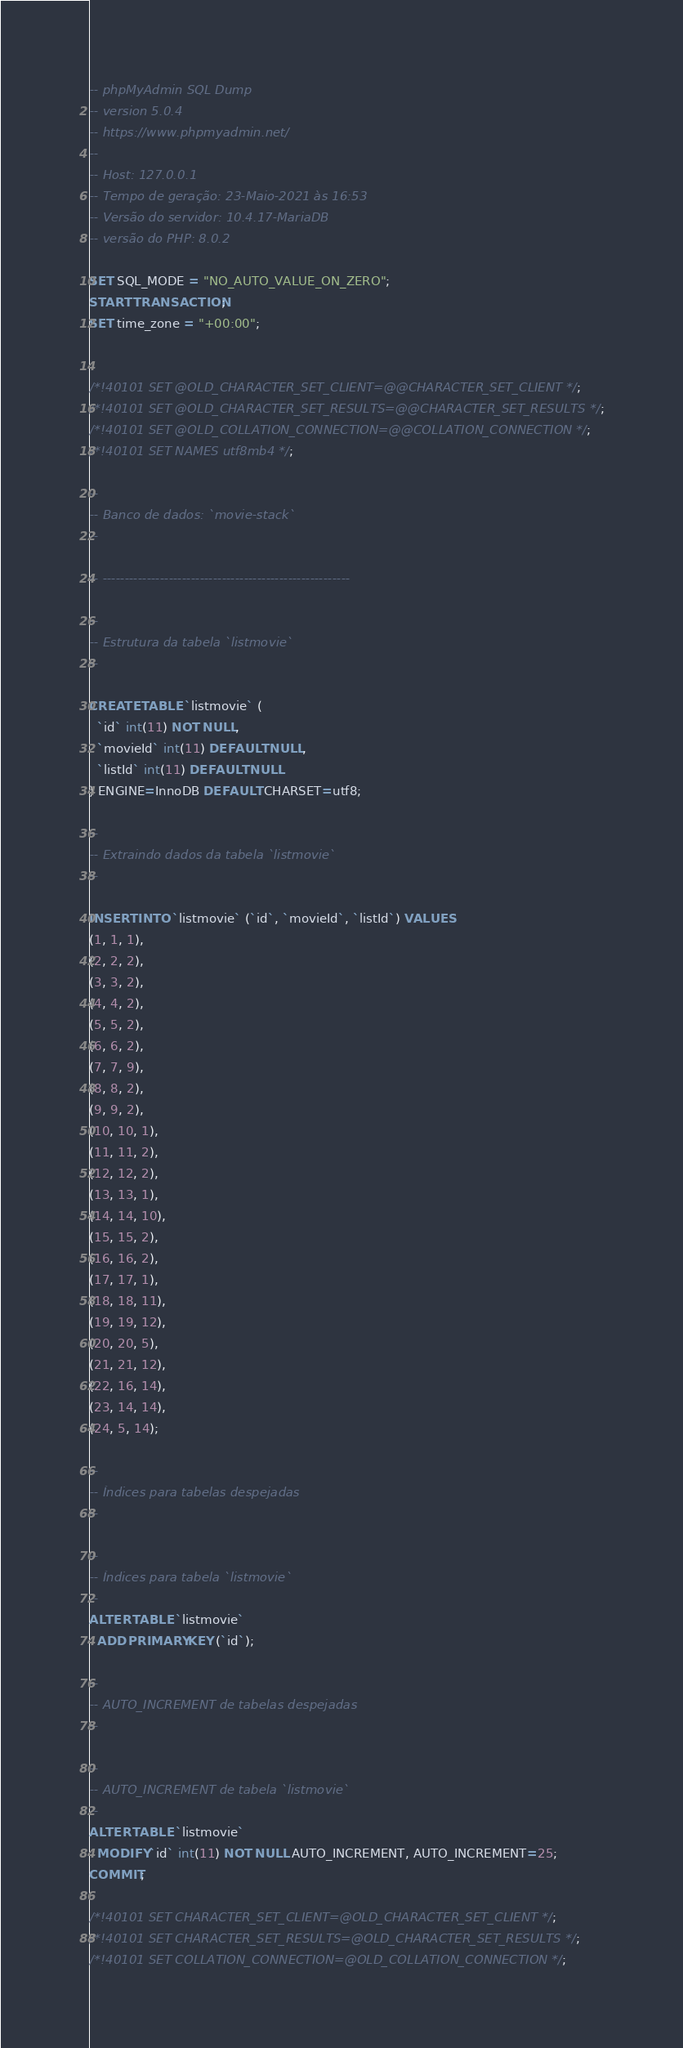<code> <loc_0><loc_0><loc_500><loc_500><_SQL_>-- phpMyAdmin SQL Dump
-- version 5.0.4
-- https://www.phpmyadmin.net/
--
-- Host: 127.0.0.1
-- Tempo de geração: 23-Maio-2021 às 16:53
-- Versão do servidor: 10.4.17-MariaDB
-- versão do PHP: 8.0.2

SET SQL_MODE = "NO_AUTO_VALUE_ON_ZERO";
START TRANSACTION;
SET time_zone = "+00:00";


/*!40101 SET @OLD_CHARACTER_SET_CLIENT=@@CHARACTER_SET_CLIENT */;
/*!40101 SET @OLD_CHARACTER_SET_RESULTS=@@CHARACTER_SET_RESULTS */;
/*!40101 SET @OLD_COLLATION_CONNECTION=@@COLLATION_CONNECTION */;
/*!40101 SET NAMES utf8mb4 */;

--
-- Banco de dados: `movie-stack`
--

-- --------------------------------------------------------

--
-- Estrutura da tabela `listmovie`
--

CREATE TABLE `listmovie` (
  `id` int(11) NOT NULL,
  `movieId` int(11) DEFAULT NULL,
  `listId` int(11) DEFAULT NULL
) ENGINE=InnoDB DEFAULT CHARSET=utf8;

--
-- Extraindo dados da tabela `listmovie`
--

INSERT INTO `listmovie` (`id`, `movieId`, `listId`) VALUES
(1, 1, 1),
(2, 2, 2),
(3, 3, 2),
(4, 4, 2),
(5, 5, 2),
(6, 6, 2),
(7, 7, 9),
(8, 8, 2),
(9, 9, 2),
(10, 10, 1),
(11, 11, 2),
(12, 12, 2),
(13, 13, 1),
(14, 14, 10),
(15, 15, 2),
(16, 16, 2),
(17, 17, 1),
(18, 18, 11),
(19, 19, 12),
(20, 20, 5),
(21, 21, 12),
(22, 16, 14),
(23, 14, 14),
(24, 5, 14);

--
-- Índices para tabelas despejadas
--

--
-- Índices para tabela `listmovie`
--
ALTER TABLE `listmovie`
  ADD PRIMARY KEY (`id`);

--
-- AUTO_INCREMENT de tabelas despejadas
--

--
-- AUTO_INCREMENT de tabela `listmovie`
--
ALTER TABLE `listmovie`
  MODIFY `id` int(11) NOT NULL AUTO_INCREMENT, AUTO_INCREMENT=25;
COMMIT;

/*!40101 SET CHARACTER_SET_CLIENT=@OLD_CHARACTER_SET_CLIENT */;
/*!40101 SET CHARACTER_SET_RESULTS=@OLD_CHARACTER_SET_RESULTS */;
/*!40101 SET COLLATION_CONNECTION=@OLD_COLLATION_CONNECTION */;
</code> 